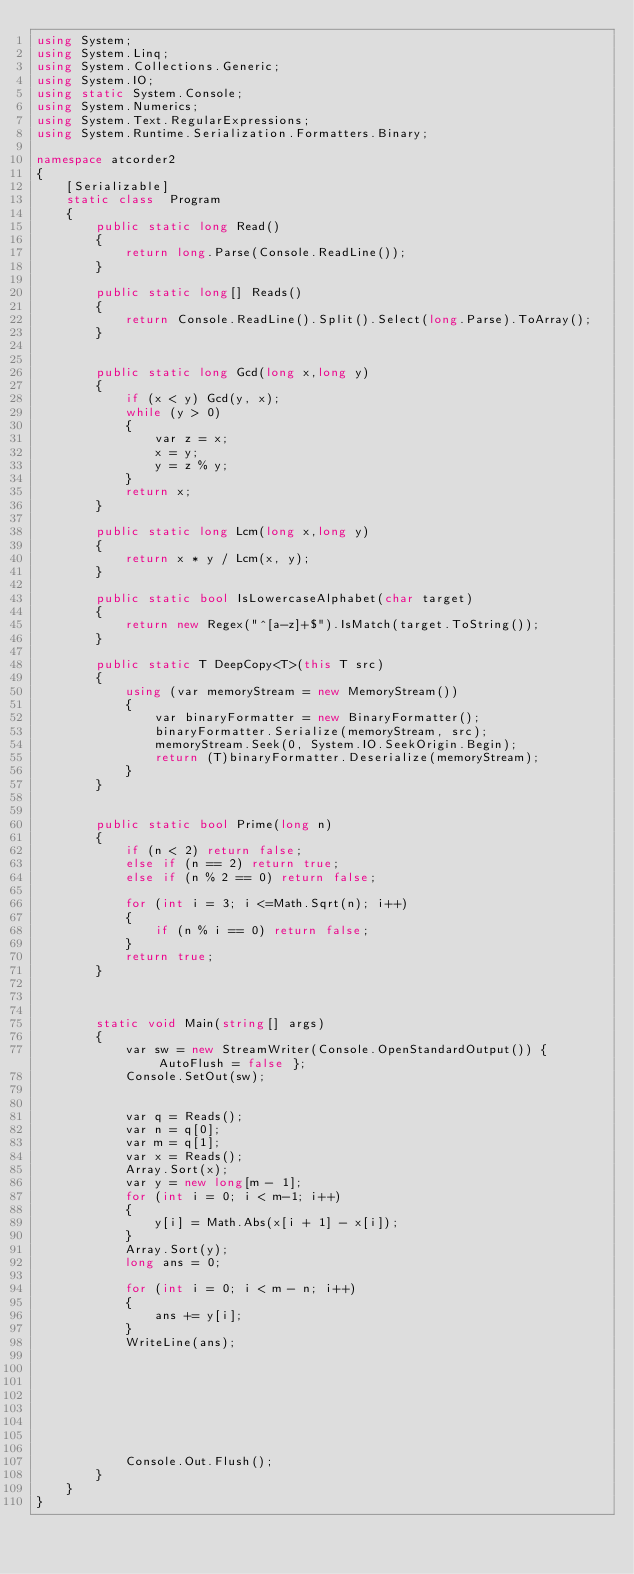Convert code to text. <code><loc_0><loc_0><loc_500><loc_500><_C#_>using System;
using System.Linq;
using System.Collections.Generic;
using System.IO;
using static System.Console;
using System.Numerics;
using System.Text.RegularExpressions;
using System.Runtime.Serialization.Formatters.Binary;

namespace atcorder2
{
    [Serializable]
    static class  Program
    {
        public static long Read()
        {
            return long.Parse(Console.ReadLine());
        }

        public static long[] Reads()
        {
            return Console.ReadLine().Split().Select(long.Parse).ToArray();
        }


        public static long Gcd(long x,long y)
        {
            if (x < y) Gcd(y, x);
            while (y > 0)
            {
                var z = x;
                x = y;
                y = z % y;
            }
            return x;
        }

        public static long Lcm(long x,long y)
        {
            return x * y / Lcm(x, y);
        }

        public static bool IsLowercaseAlphabet(char target)
        {
            return new Regex("^[a-z]+$").IsMatch(target.ToString());
        }

        public static T DeepCopy<T>(this T src)
        {
            using (var memoryStream = new MemoryStream())
            {
                var binaryFormatter = new BinaryFormatter();
                binaryFormatter.Serialize(memoryStream, src);
                memoryStream.Seek(0, System.IO.SeekOrigin.Begin);
                return (T)binaryFormatter.Deserialize(memoryStream);
            }
        }


        public static bool Prime(long n)
        {
            if (n < 2) return false;
            else if (n == 2) return true;
            else if (n % 2 == 0) return false;

            for (int i = 3; i <=Math.Sqrt(n); i++)
            {
                if (n % i == 0) return false;
            }
            return true;
        }
        


        static void Main(string[] args)
        {
            var sw = new StreamWriter(Console.OpenStandardOutput()) { AutoFlush = false };
            Console.SetOut(sw);


            var q = Reads();
            var n = q[0];
            var m = q[1];
            var x = Reads();
            Array.Sort(x);
            var y = new long[m - 1];
            for (int i = 0; i < m-1; i++)
            {
                y[i] = Math.Abs(x[i + 1] - x[i]);
            }
            Array.Sort(y);
            long ans = 0;

            for (int i = 0; i < m - n; i++)
            {
                ans += y[i];
            }
            WriteLine(ans);
            
            
            
           

           


            Console.Out.Flush();
        }
    }
}

</code> 